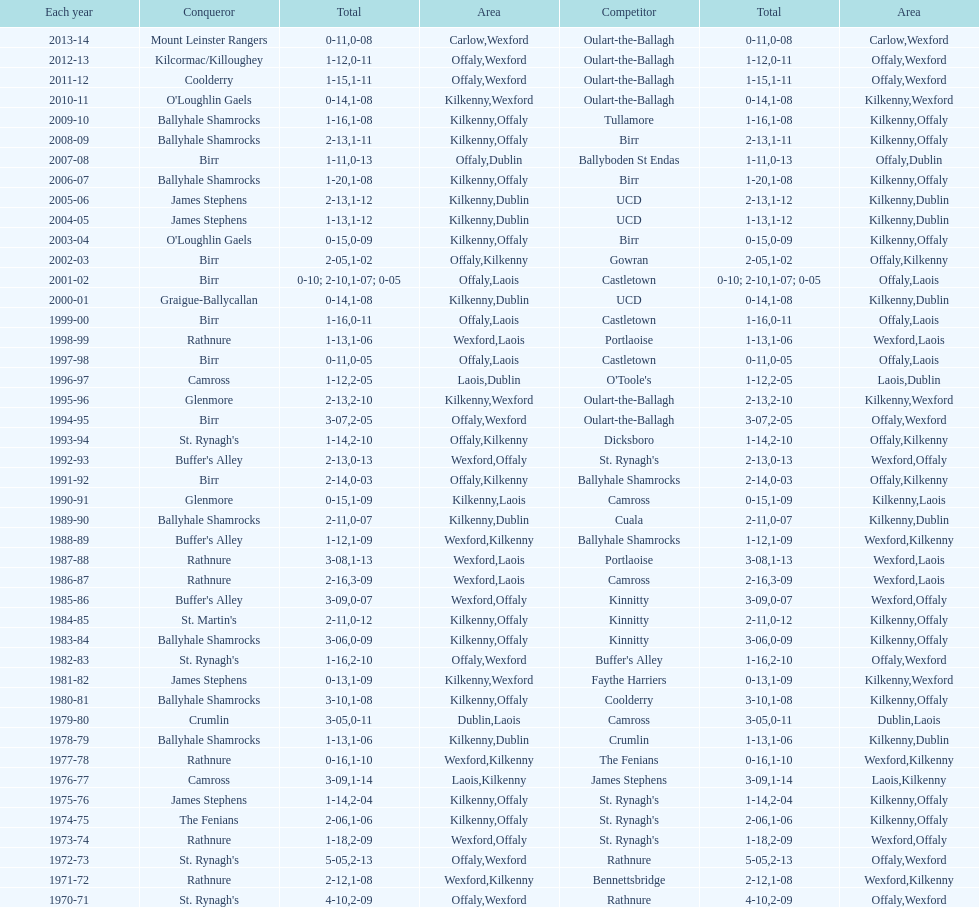Which country had the most wins? Kilkenny. 